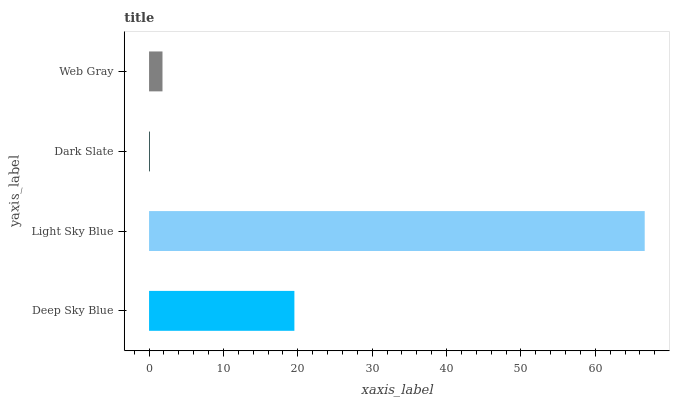Is Dark Slate the minimum?
Answer yes or no. Yes. Is Light Sky Blue the maximum?
Answer yes or no. Yes. Is Light Sky Blue the minimum?
Answer yes or no. No. Is Dark Slate the maximum?
Answer yes or no. No. Is Light Sky Blue greater than Dark Slate?
Answer yes or no. Yes. Is Dark Slate less than Light Sky Blue?
Answer yes or no. Yes. Is Dark Slate greater than Light Sky Blue?
Answer yes or no. No. Is Light Sky Blue less than Dark Slate?
Answer yes or no. No. Is Deep Sky Blue the high median?
Answer yes or no. Yes. Is Web Gray the low median?
Answer yes or no. Yes. Is Dark Slate the high median?
Answer yes or no. No. Is Dark Slate the low median?
Answer yes or no. No. 